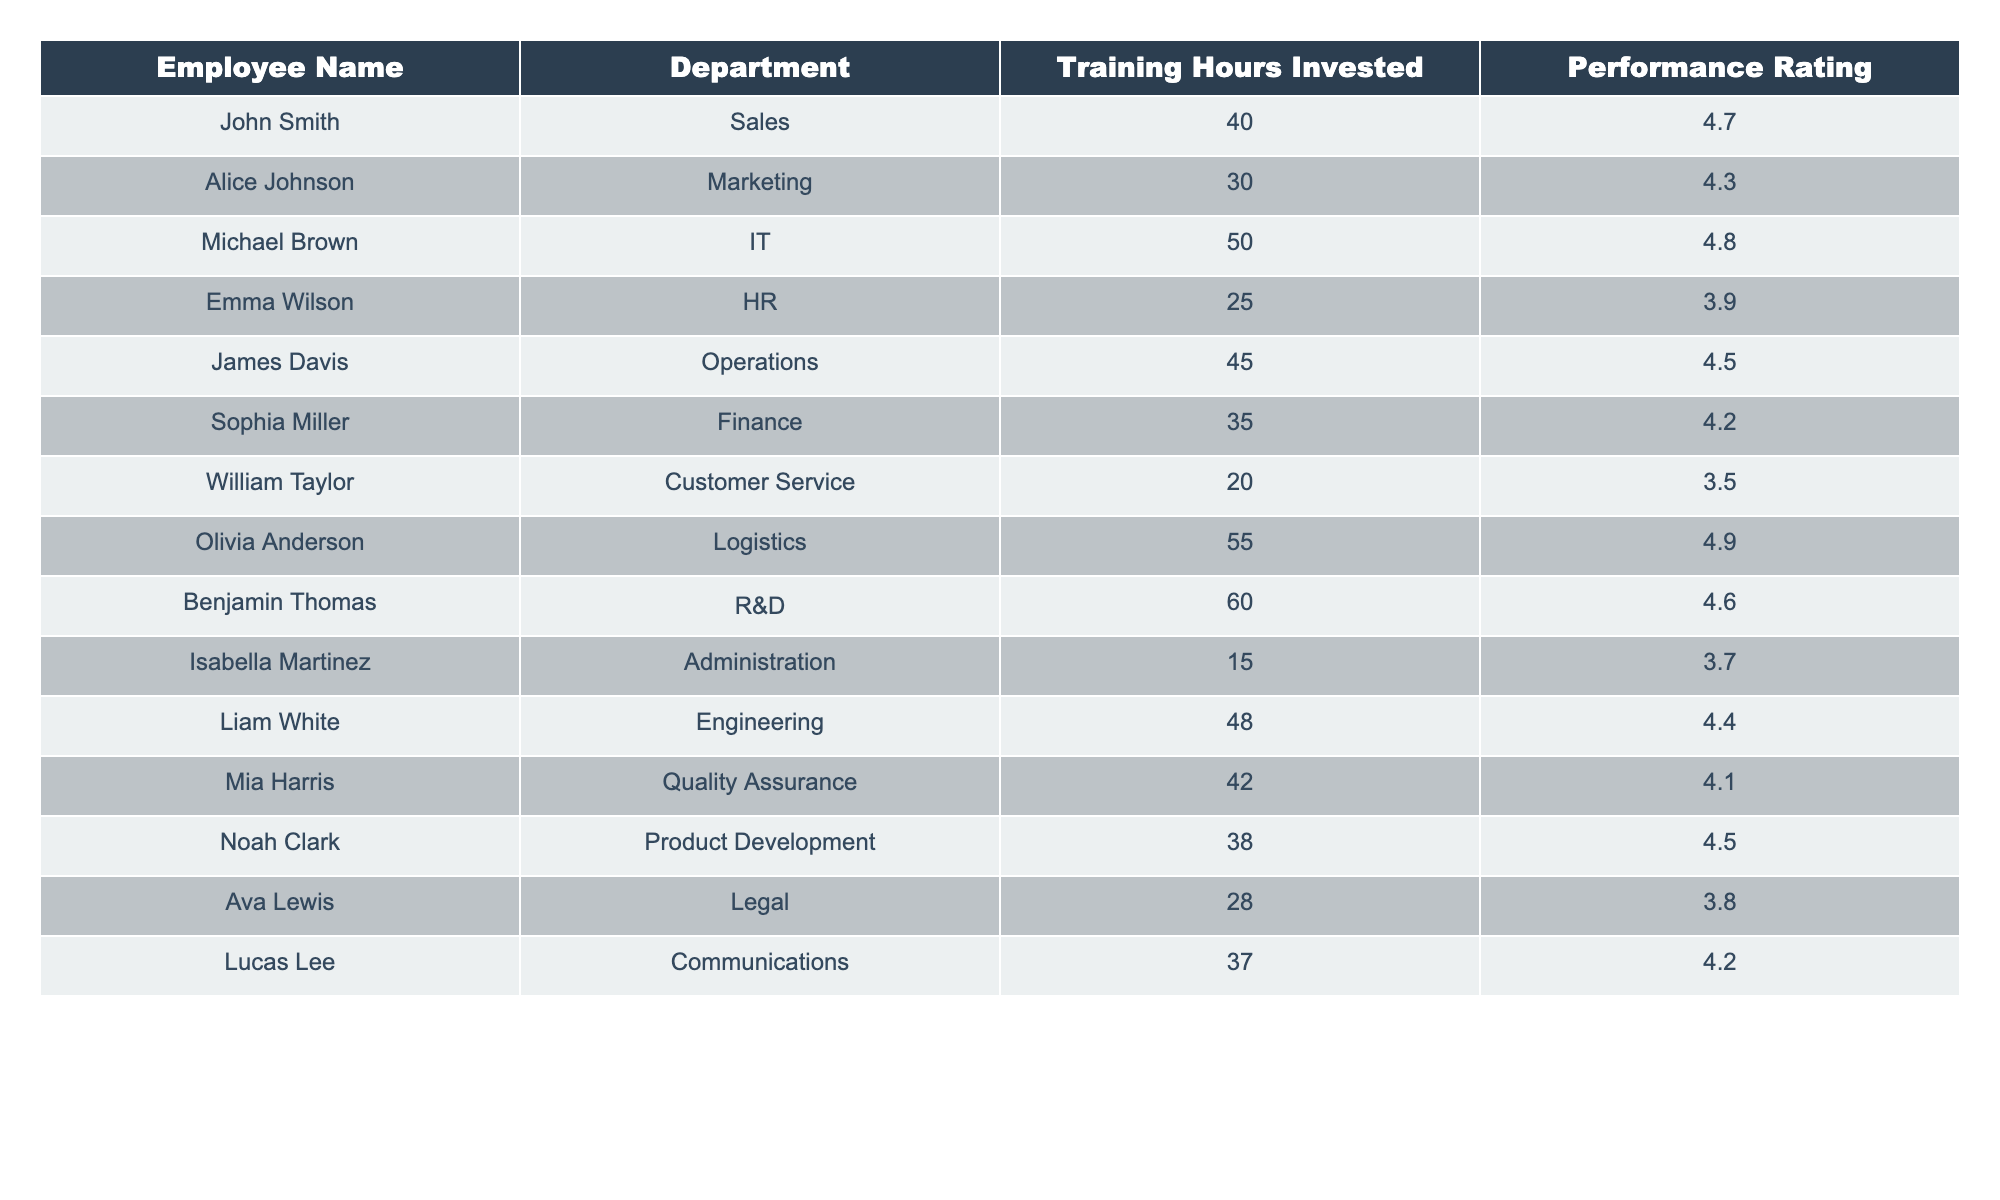What is the highest performance rating in the table? The performance ratings are 4.7, 4.3, 4.8, 3.9, 4.5, 4.2, 3.5, 4.9, 4.6, 3.7, 4.4, 4.1, 4.5, 3.8, and 4.2. The highest of these values is 4.9.
Answer: 4.9 How many training hours were invested by Benjamin Thomas? Looking at the table, Benjamin Thomas has 60 training hours invested listed next to his name.
Answer: 60 What is the average performance rating of employees who invested more than 40 training hours? The employees who invested more than 40 training hours are Michael Brown (4.8), James Davis (4.5), Olivia Anderson (4.9), Benjamin Thomas (4.6), Liam White (4.4), and Mia Harris (4.1). Summing their ratings gives 4.8 + 4.5 + 4.9 + 4.6 + 4.4 + 4.1 = 27.3 and dividing by 6 (the number of employees) gives an average of 27.3 / 6 ≈ 4.55.
Answer: 4.55 Is there any employee in the Customer Service department with a performance rating above 4.0? William Taylor works in Customer Service with a performance rating of 3.5. Since 3.5 is not above 4.0, the answer is no.
Answer: No What is the difference in performance ratings between the employee with the most training hours and the employee with the least training hours? The employee with the most training hours is Benjamin Thomas with a rating of 4.6, while the employee with the least training hours is Isabella Martinez with a rating of 3.7. Calculating the difference gives 4.6 - 3.7 = 0.9.
Answer: 0.9 Which department has the lowest average performance rating? The average performance rating can be calculated per department. For example, HR has a performance rating of 3.9, Customer Service has 3.5, Administration has 3.7, and Legal has 3.8. The lowest average rating is in Customer Service with a rating of 3.5.
Answer: Customer Service Who is the employee with the second-highest performance rating and how many training hours did they invest? The performance ratings in descending order are: Olivia Anderson (4.9), Michael Brown (4.8), Benjamin Thomas (4.6), James Davis (4.5), and Liam White (4.4). The second-highest performance rating is thus 4.8, which belongs to Michael Brown. He invested 50 training hours.
Answer: Michael Brown, 50 How many employees have performance ratings above 4.0? By examining each performance rating, the employees with ratings above 4.0 are John Smith (4.7), Michael Brown (4.8), James Davis (4.5), Sophia Miller (4.2), Olivia Anderson (4.9), Benjamin Thomas (4.6), Liam White (4.4), and Mia Harris (4.1) totaling 8 employees.
Answer: 8 What percentage of employees have invested less than 30 training hours? There are 15 employees total. The employees who invested less than 30 hours are William Taylor (20), and Isabella Martinez (15), totaling 2. To find the percentage, calculate (2/15) * 100 which equals approximately 13.33%.
Answer: 13.33% Is the average training hours invested less for the Finance department compared to the Operations department? The Finance department employees invested 35 training hours, while the Operations department employees invested 45 training hours. So, the average for Finance (35) is less than that for Operations (45).
Answer: Yes 